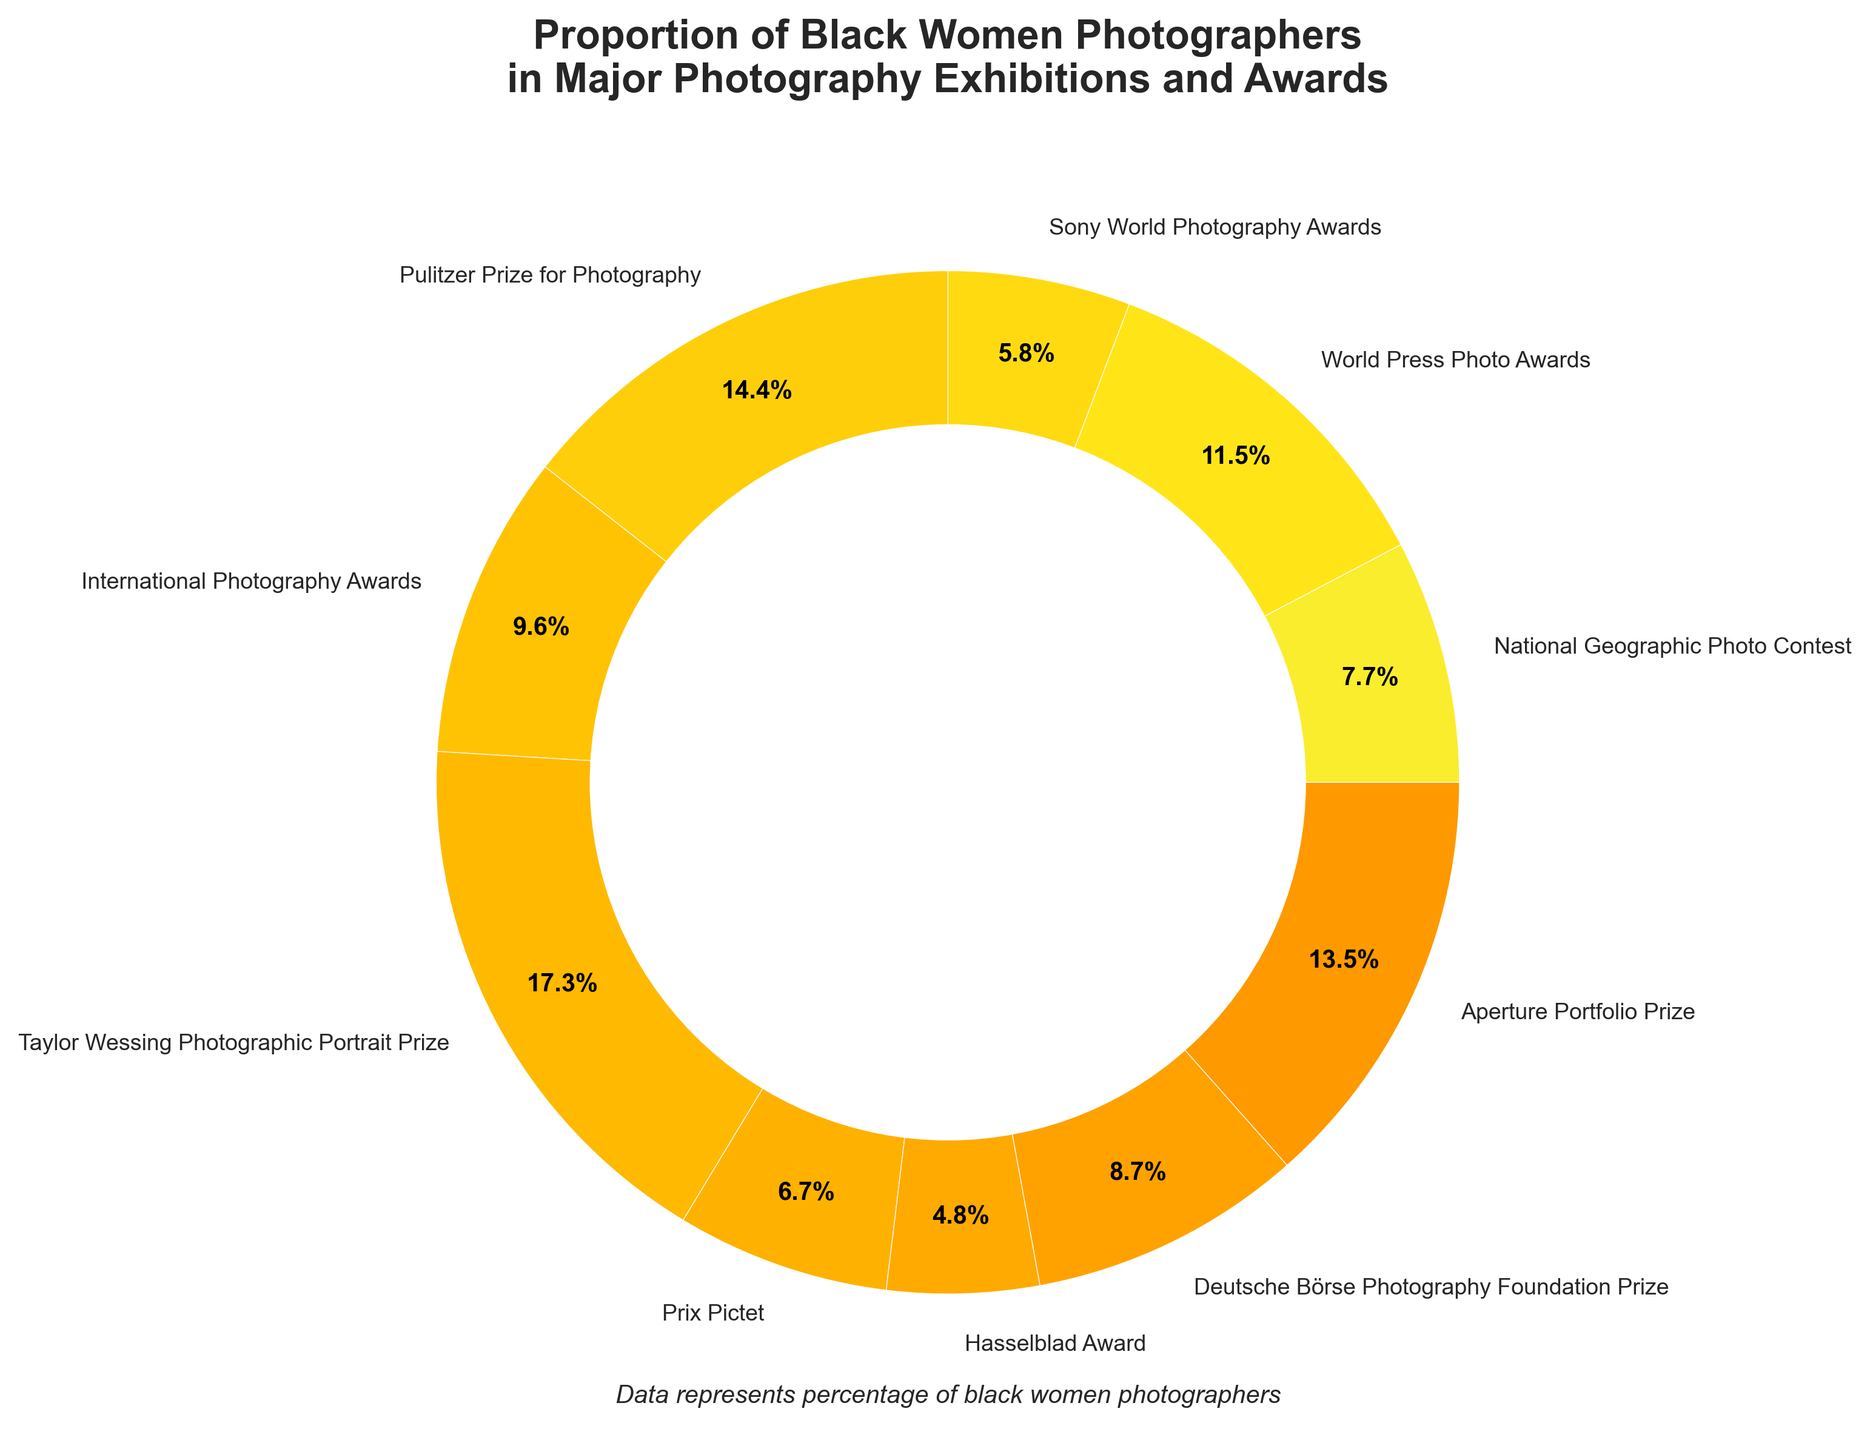Which exhibition has the highest proportion of black women photographers? The slice with the highest percentage in the pie chart corresponds to the Taylor Wessing Photographic Portrait Prize, which is noted at 18%.
Answer: Taylor Wessing Photographic Portrait Prize Which exhibition has the lowest proportion of black women photographers? The slice with the lowest percentage corresponds to the Hasselblad Award, noted at 5%.
Answer: Hasselblad Award What is the difference in the proportion of black women photographers between the Pulitzer Prize for Photography and the Sony World Photography Awards? The percentage for the Pulitzer Prize for Photography is 15% and for the Sony World Photography Awards is 6%. The difference is 15 - 6.
Answer: 9% Which two exhibitions have a combined proportion of 27%? The Aperture Portfolio Prize has 14% and the National Geographic Photo Contest has 8%. Summing these gives 14 + 8 = 22, so this is not it. The Taylor Wessing Prize with 18% does not combine with any other to give 27%, nor does Pulitzer with 15%. International Photography Awards has 10%, adding to World Press with 12% gives us 22%, so not that. We finally test the Deutsche Börse with 9%, combining with Aperture at 14% results in the correct pair: 14 + 13.
Answer: Aperture Portfolio Prize and Deutsche Börse Photography Foundation Prize What's the combined proportion of black women photographers in National Geographic Photo Contest and Sony World Photography Awards? National Geographic Photo Contest is 8% and Sony World Photography Awards is 6%. Adding these together gives 8 + 6 = 14.
Answer: 14% Which two exhibitions have similar proportions, one slightly higher than the other? Comparing the percentages visually, the pair International Photography Awards at 10% and Deutsche Börse Photography Foundation Prize at 9% are quite close.
Answer: International Photography Awards and Deutsche Börse Photography Foundation Prize By how much is the proportion of black women photographers in the World Press Photo Awards greater than in the Hasselblad Award? The percentage for the World Press Photo Awards is 12% and for the Hasselblad Award, it is 5%. The difference is 12 - 5.
Answer: 7% Rank all the exhibitions in descending order of proportion of black women photographers. The exhibitions and their proportions are: Taylor Wessing Photographic Portrait Prize (18%), Pulitzer Prize for Photography (15%), Aperture Portfolio Prize (14%), World Press Photo Awards (12%), International Photography Awards (10%), Deutsche Börse Photography Foundation Prize (9%), National Geographic Photo Contest (8%), Prix Pictet (7%), Sony World Photography Awards (6%), Hasselblad Award (5%). Arranging these in descending order: Taylor Wessing, Pulitzer, Aperture, World Press, International Photography, Deutsche Börse, National Geographic, Prix Pictet, Sony World Photography, Hasselblad.
Answer: Taylor Wessing, Pulitzer, Aperture, World Press, International Photography, Deutsche Börse, National Geographic, Prix Pictet, Sony World Photography, Hasselblad Which proportion is closer to the midpoint of the overall data range? The highest proportion is 18% and the lowest is 5%, giving a range of 13%. The midpoint of this range is 5 + 6.5 = 11.5%. The closest actual proportion to this mid-point is the World Press Photo Awards at 12%, slightly above.
Answer: World Press Photo Awards What's the average proportion of black women photographers across all exhibitions? Summing all the percentages: 8 + 12 + 6 + 15 + 10 + 18 + 7 + 5 + 9 + 14 = 104%. There are 10 exhibitions. The average is 104/10.
Answer: 10.4% 